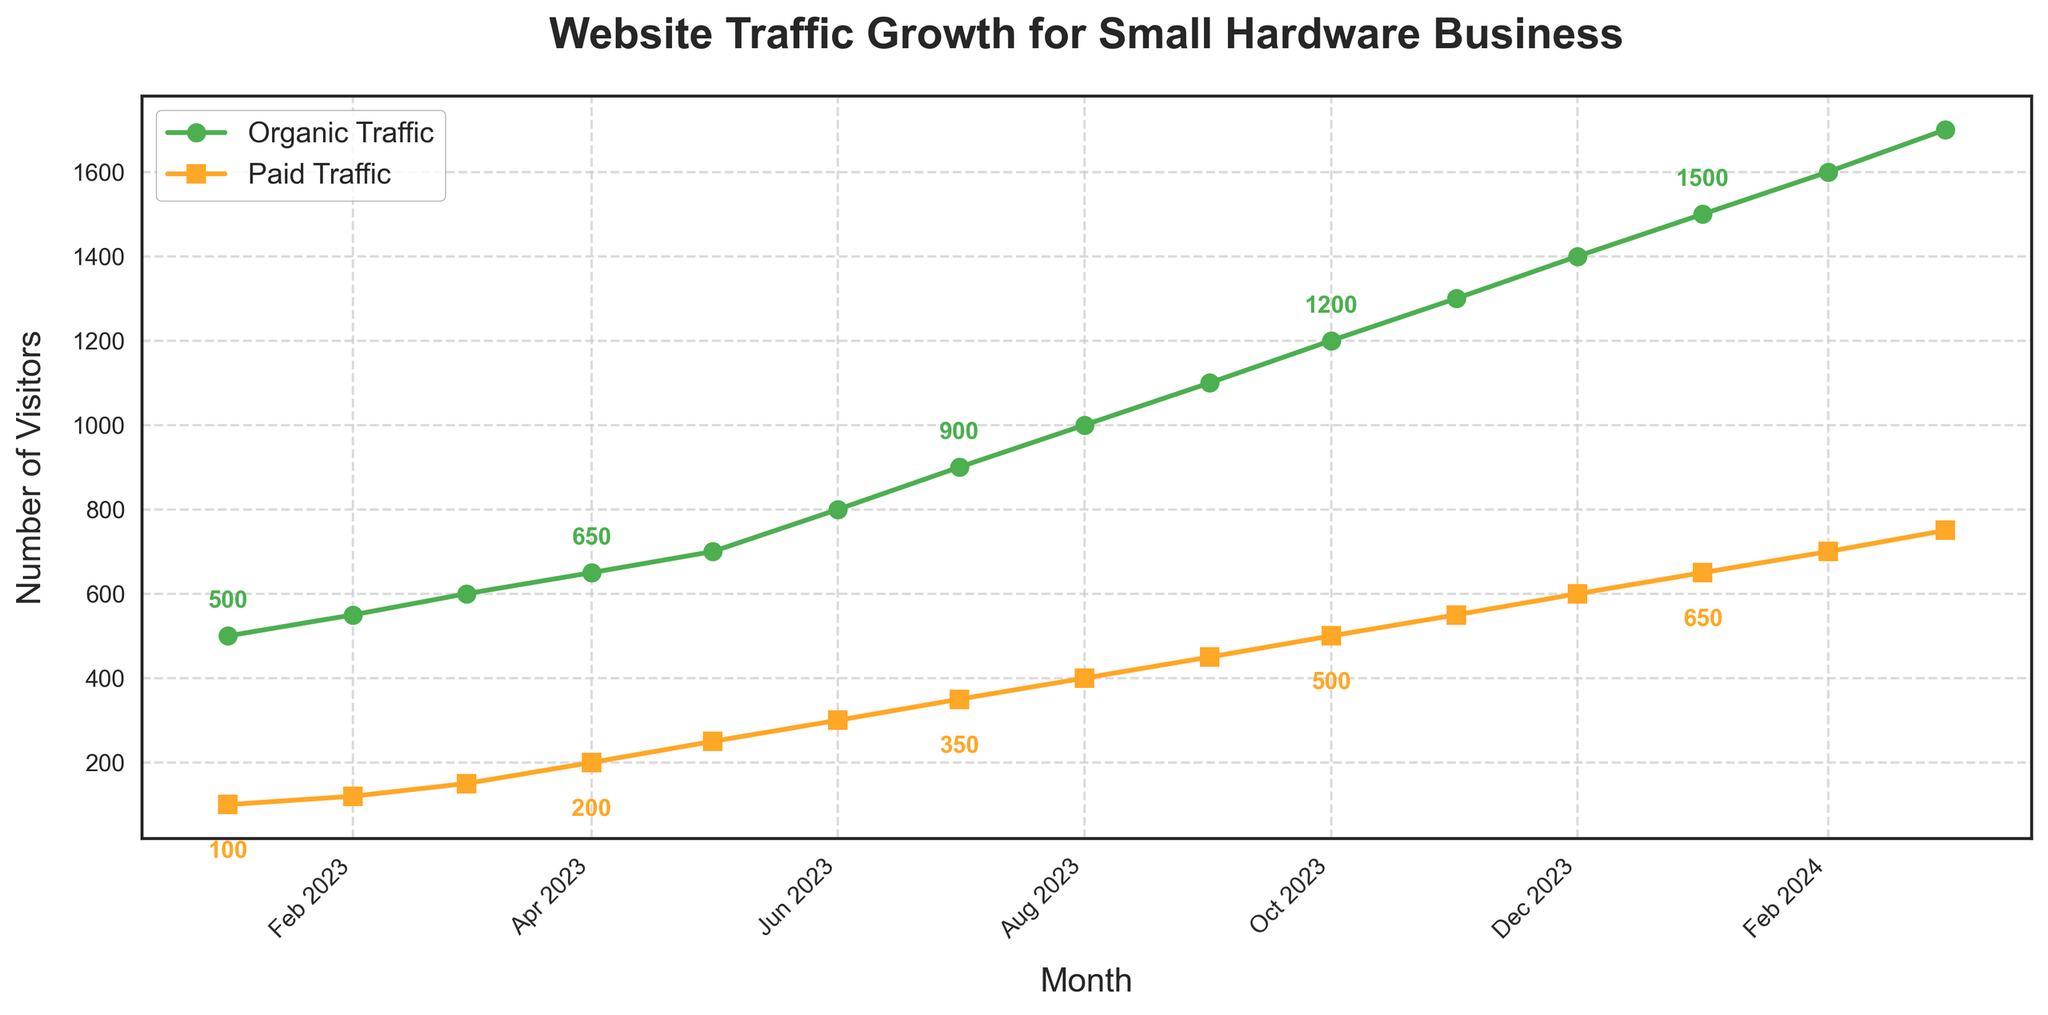What is the total number of organic visitors from Jan 2023 to Dec 2023? Calculate the sum of organic visitors from Jan 2023 and Dec 2023. The monthly organic visitors are: 500, 550, 600, 650, 700, 800, 900, 1000, 1100, 1200, 1300, 1400. The total is \(500 + 550 + 600 + 650 + 700 + 800 + 900 + 1000 + 1100 + 1200 + 1300 + 1400 = 11700\).
Answer: 11700 Which month saw the highest increase in organic traffic compared to the previous month from Jan 2023 to Mar 2024? Examine the increase in organic traffic month-over-month. The differences are: Feb (50), Mar (50), Apr (50), May (50), Jun (100), Jul (100), Aug (100), Sep (100), Oct (100), Nov (100), Dec (100), Jan 2024 (100), Feb 2024 (100), Mar 2024 (100). The highest increase is from May 2023 to Jun 2023, which is 100.
Answer: Jun 2023 In which month does paid traffic first reach 300 visitors? Examine the data points for paid traffic each month and identify when it first reaches 300 visitors. In Jun 2023, the paid traffic is 300 visitors.
Answer: Jun 2023 What is the difference between organic and paid traffic in Nov 2023? Look at the values for organic and paid traffic in Nov 2023, which are 1300 and 550 respectively. The difference is \(1300 - 550 = 750\).
Answer: 750 How does the trend of organic traffic compare to paid traffic overall? Both organic and paid traffic exhibit an upward trend over time. Organic traffic increases consistently, growing by approximately 100 visitors each month from Jun 2023 onward. Paid traffic also increases steadily but starts from a lower base of 100 visitors and grows by approximately 50 visitors each month from Jul 2023 onward.
Answer: Both increase steadily; organic grows more rapidly By how many visitors did the paid traffic increase from Jan 2023 to Dec 2023? The paid traffic in Jan 2023 is 100 visitors, and in Dec 2023 it is 600 visitors. The increase is \(600 - 100 = 500\).
Answer: 500 In which month do both organic and paid traffic align in showing a prominent step-up in growth? Review monthly changes and identify a common month where both organic (900 to 1000) and paid (350 to 400) traffic exhibit significant increases. August 2023 marks this shared surge, with both metrics increasing by 100 visitors.
Answer: Aug 2023 Which month represents the lowest point of both organic and paid traffic? The lowest values are seen in Jan 2023 with 500 for organic and 100 for paid traffic, respectively. Therefore, January 2023 is the lowest month for both.
Answer: Jan 2023 